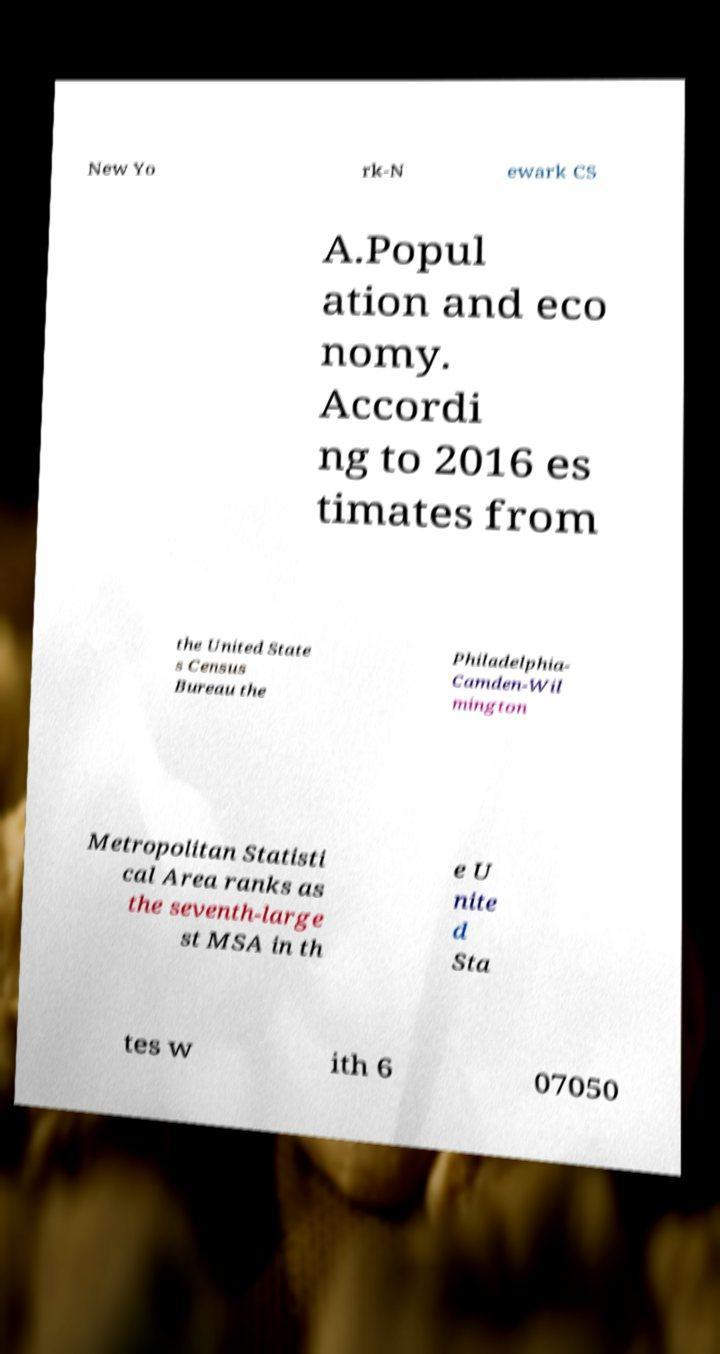Please identify and transcribe the text found in this image. New Yo rk-N ewark CS A.Popul ation and eco nomy. Accordi ng to 2016 es timates from the United State s Census Bureau the Philadelphia- Camden-Wil mington Metropolitan Statisti cal Area ranks as the seventh-large st MSA in th e U nite d Sta tes w ith 6 07050 